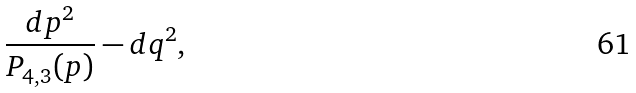<formula> <loc_0><loc_0><loc_500><loc_500>\frac { d p ^ { 2 } } { P _ { 4 , 3 } ( p ) } - { d q ^ { 2 } } ,</formula> 